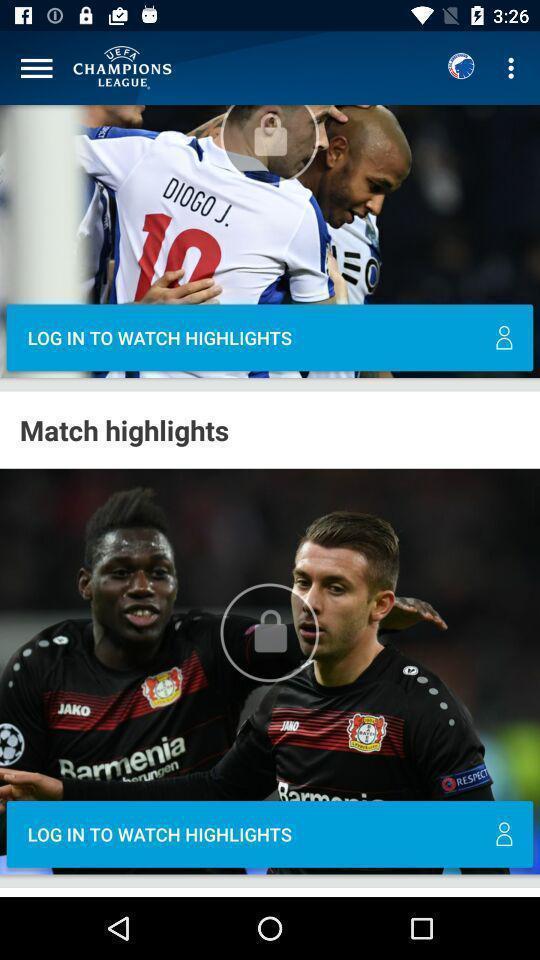What can you discern from this picture? Page showing videos in sports app. 